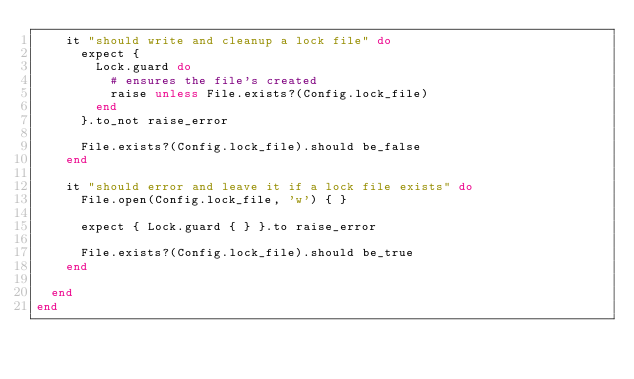<code> <loc_0><loc_0><loc_500><loc_500><_Ruby_>    it "should write and cleanup a lock file" do
      expect {
        Lock.guard do
          # ensures the file's created
          raise unless File.exists?(Config.lock_file)
        end
      }.to_not raise_error

      File.exists?(Config.lock_file).should be_false
    end

    it "should error and leave it if a lock file exists" do
      File.open(Config.lock_file, 'w') { }

      expect { Lock.guard { } }.to raise_error

      File.exists?(Config.lock_file).should be_true
    end

  end
end
</code> 